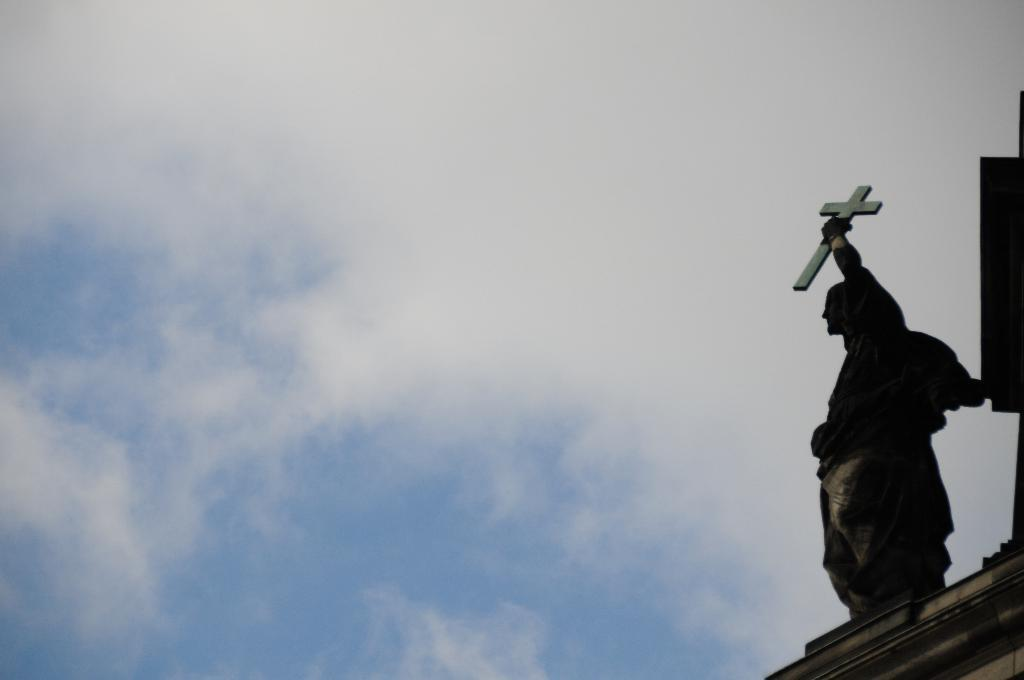What is the main subject of the image? There is a statue of a man in the image. What can be seen in the background of the image? The sky is visible in the background of the image. How many cows are present on the stage in the image? There are no cows or stage present in the image; it features a statue of a man with a sky background. 